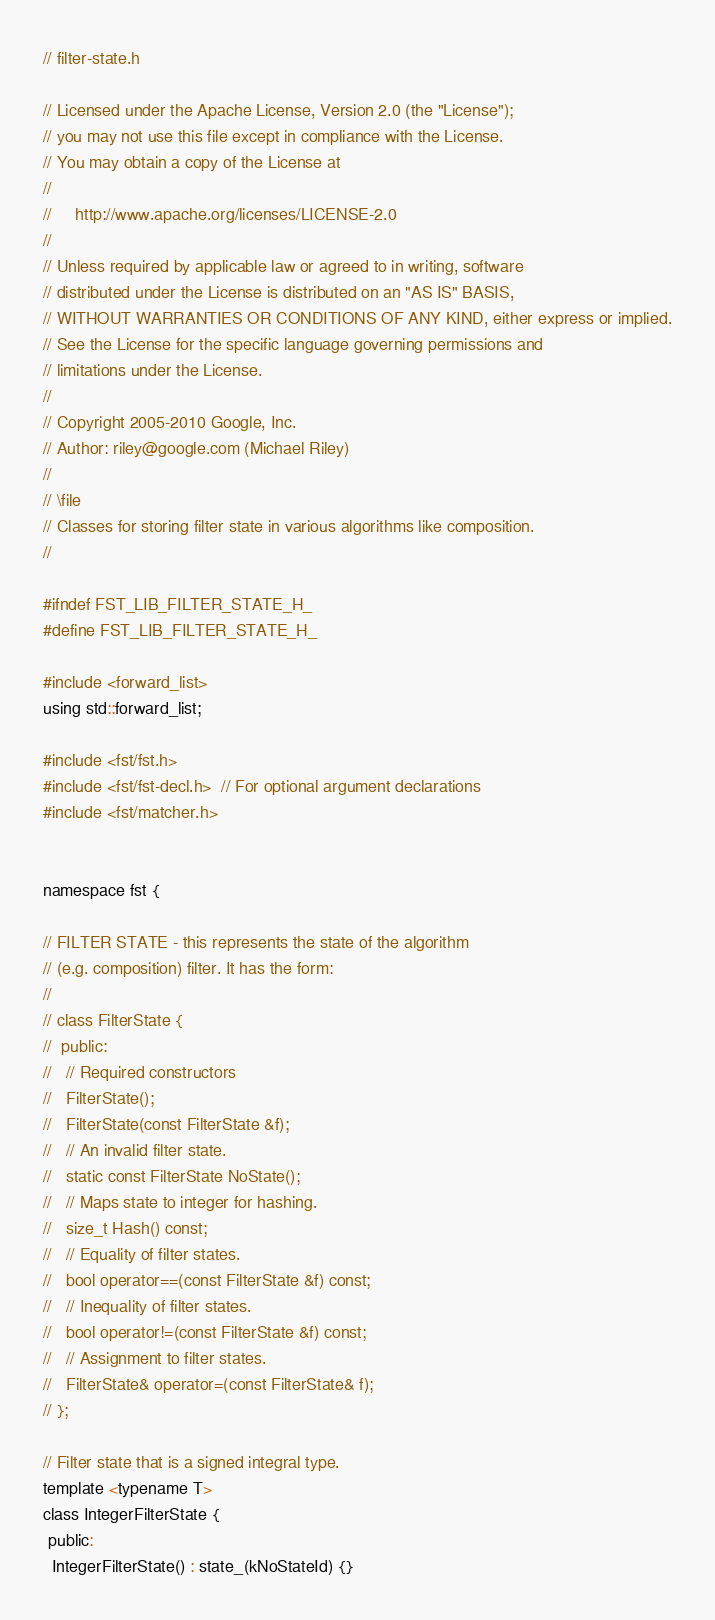Convert code to text. <code><loc_0><loc_0><loc_500><loc_500><_C_>// filter-state.h

// Licensed under the Apache License, Version 2.0 (the "License");
// you may not use this file except in compliance with the License.
// You may obtain a copy of the License at
//
//     http://www.apache.org/licenses/LICENSE-2.0
//
// Unless required by applicable law or agreed to in writing, software
// distributed under the License is distributed on an "AS IS" BASIS,
// WITHOUT WARRANTIES OR CONDITIONS OF ANY KIND, either express or implied.
// See the License for the specific language governing permissions and
// limitations under the License.
//
// Copyright 2005-2010 Google, Inc.
// Author: riley@google.com (Michael Riley)
//
// \file
// Classes for storing filter state in various algorithms like composition.
//

#ifndef FST_LIB_FILTER_STATE_H_
#define FST_LIB_FILTER_STATE_H_

#include <forward_list>
using std::forward_list;

#include <fst/fst.h>
#include <fst/fst-decl.h>  // For optional argument declarations
#include <fst/matcher.h>


namespace fst {

// FILTER STATE - this represents the state of the algorithm
// (e.g. composition) filter. It has the form:
//
// class FilterState {
//  public:
//   // Required constructors
//   FilterState();
//   FilterState(const FilterState &f);
//   // An invalid filter state.
//   static const FilterState NoState();
//   // Maps state to integer for hashing.
//   size_t Hash() const;
//   // Equality of filter states.
//   bool operator==(const FilterState &f) const;
//   // Inequality of filter states.
//   bool operator!=(const FilterState &f) const;
//   // Assignment to filter states.
//   FilterState& operator=(const FilterState& f);
// };

// Filter state that is a signed integral type.
template <typename T>
class IntegerFilterState {
 public:
  IntegerFilterState() : state_(kNoStateId) {}</code> 